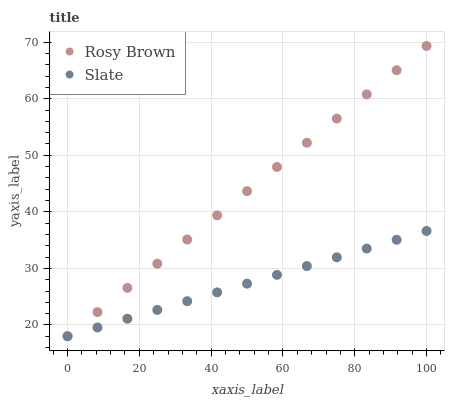Does Slate have the minimum area under the curve?
Answer yes or no. Yes. Does Rosy Brown have the maximum area under the curve?
Answer yes or no. Yes. Does Rosy Brown have the minimum area under the curve?
Answer yes or no. No. Is Rosy Brown the smoothest?
Answer yes or no. Yes. Is Slate the roughest?
Answer yes or no. Yes. Is Rosy Brown the roughest?
Answer yes or no. No. Does Slate have the lowest value?
Answer yes or no. Yes. Does Rosy Brown have the highest value?
Answer yes or no. Yes. Does Rosy Brown intersect Slate?
Answer yes or no. Yes. Is Rosy Brown less than Slate?
Answer yes or no. No. Is Rosy Brown greater than Slate?
Answer yes or no. No. 